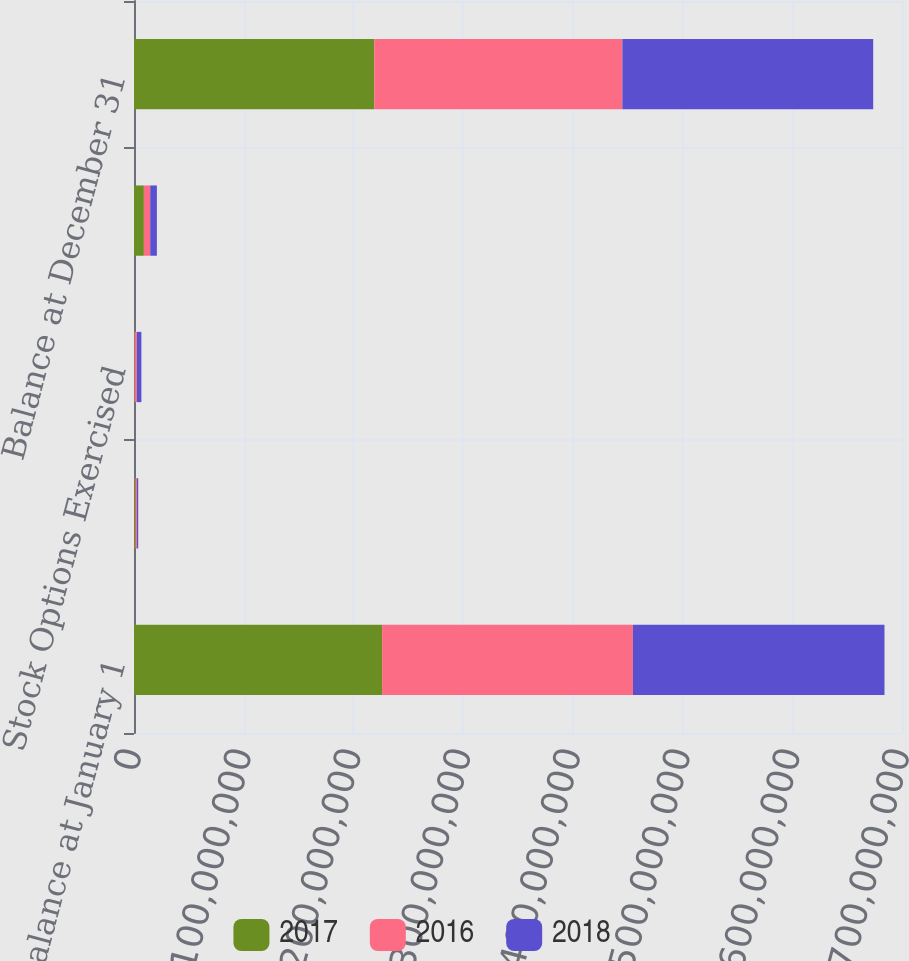Convert chart to OTSL. <chart><loc_0><loc_0><loc_500><loc_500><stacked_bar_chart><ecel><fcel>Balance at January 1<fcel>Incentive Plan and Awards<fcel>Stock Options Exercised<fcel>Treasury Stock Purchased<fcel>Balance at December 31<nl><fcel>2017<fcel>2.26127e+08<fcel>1.31078e+06<fcel>575662<fcel>9.00106e+06<fcel>2.19012e+08<nl><fcel>2016<fcel>2.28605e+08<fcel>1.32013e+06<fcel>1.99736e+06<fcel>5.7963e+06<fcel>2.26127e+08<nl><fcel>2018<fcel>2.29294e+08<fcel>1.20912e+06<fcel>4.15673e+06<fcel>6.05415e+06<fcel>2.28605e+08<nl></chart> 